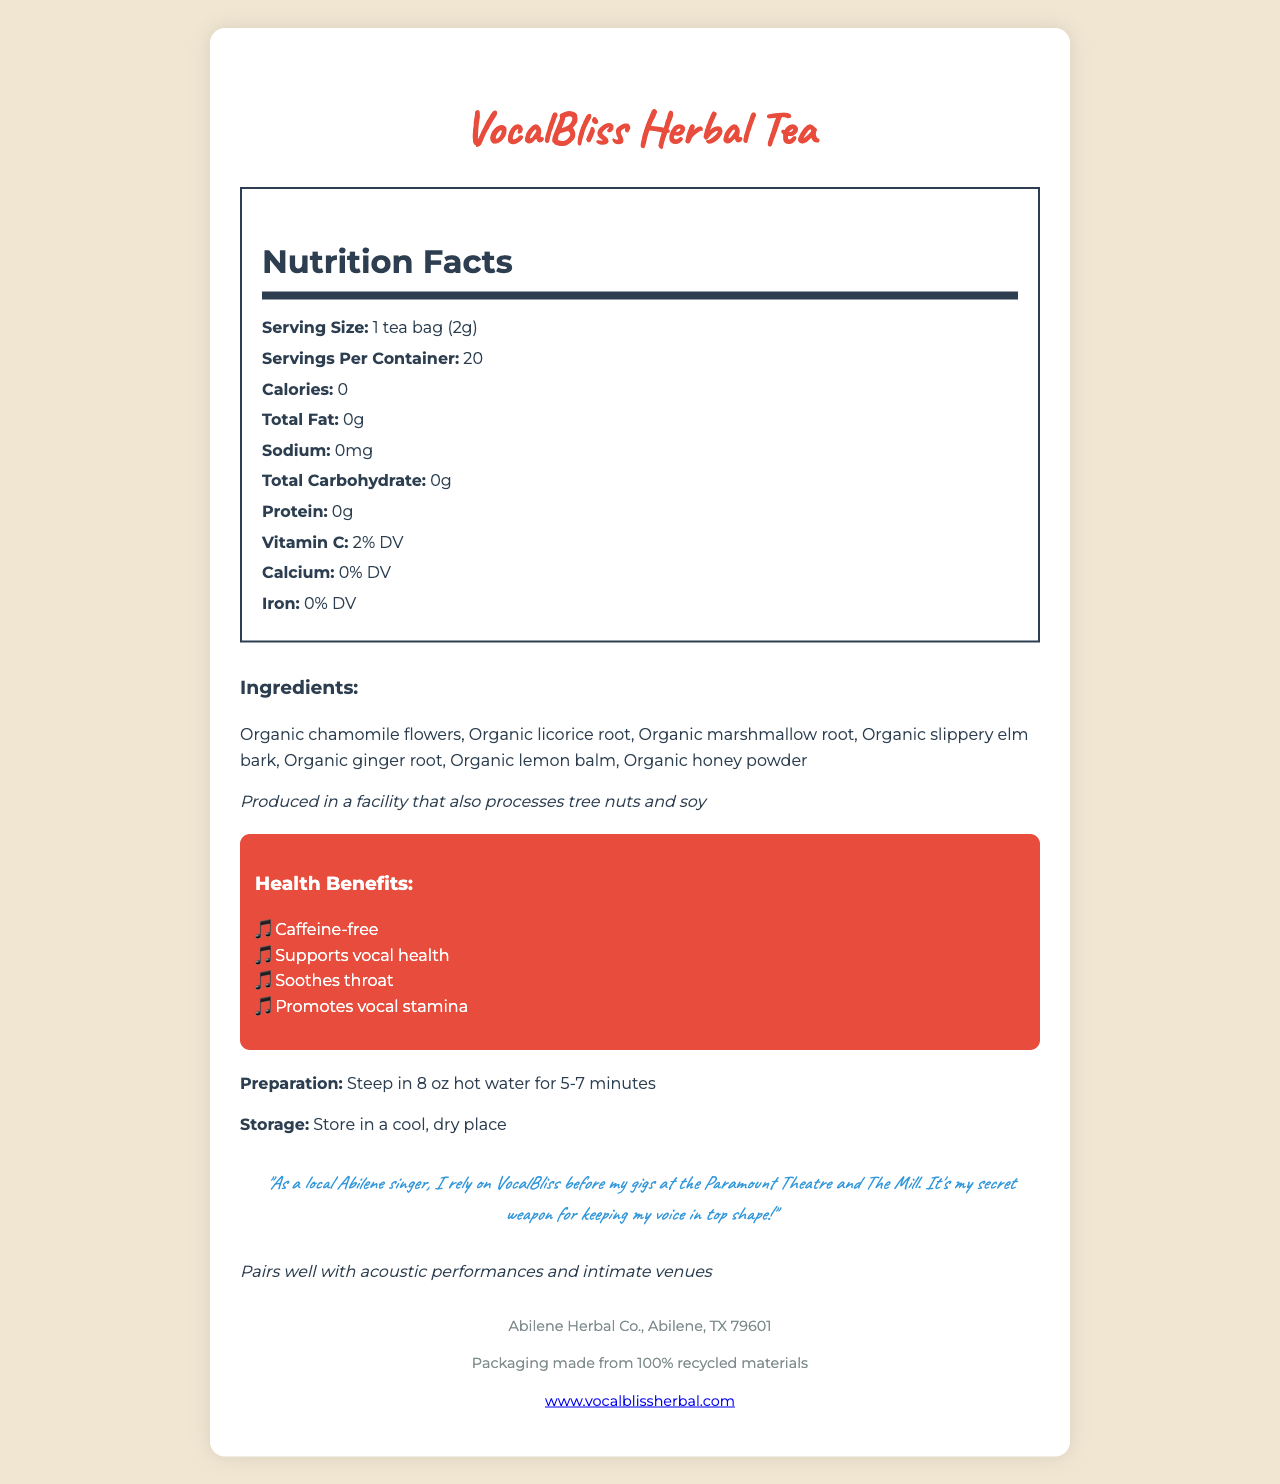what is the serving size of VocalBliss Herbal Tea? The document lists the serving size directly in the Nutrition Facts section as "1 tea bag (2g)".
Answer: 1 tea bag (2g) how many servings are there in one container? The document specifies there are 20 servings per container in the Nutrition Facts section.
Answer: 20 what is the calorie content per serving? The Nutrition Facts section indicates that the calorie content per serving is 0.
Answer: 0 what ingredient might cause an allergic reaction? The allergen information provided in the document states that it is produced in a facility that also processes tree nuts and soy.
Answer: Produced in a facility that also processes tree nuts and soy how should VocalBliss Herbal Tea be stored? The storage instructions are given as "Store in a cool, dry place" in the relevant section.
Answer: Store in a cool, dry place which manufacturer produces VocalBliss Herbal Tea? A. Herbal Health Co. B. Abilene Herbal Co. C. Texan Tea Co. The manufacturer listed at the bottom of the document is "Abilene Herbal Co."
Answer: B. Abilene Herbal Co. what percentage of Vitamin C is in one serving? The Nutrition Facts section shows that the tea contains 2% of the daily value (DV) of Vitamin C per serving.
Answer: 2% DV which of the following is an ingredient in VocalBliss Herbal Tea? I. Organic chamomile flowers II. Organic licorice root III. Organic ginger root IV. Organic green tea The ingredients list includes Organic chamomile flowers, Organic licorice root, and Organic ginger root but not Organic green tea.
Answer: I, II, and III is VocalBliss Herbal Tea caffeinated? The health benefits section lists "Caffeine-free" as one of the claims.
Answer: No does VocalBliss Herbal Tea contain any sodium? The Nutrition Facts section indicates that the sodium content is 0mg per serving.
Answer: No summarize the main idea of this document. The document showcases the nutritional information, ingredients, health claims, preparation and storage instructions, a singer's testimonial, and the manufacturer details of the VocalBliss Herbal Tea.
Answer: VocalBliss Herbal Tea is a caffeine-free herbal tea blend designed to support vocal health and stamina, containing ingredients like chamomile and ginger, produced by Abilene Herbal Co. can you list the nutritional content of VocalBliss Herbal Tea? The information for Total Fat, Sodium, Total Carbohydrate, and Protein is given as 0g, but the document does not specify any other macronutrient details beyond Vitamin C, Calcium, and Iron.
Answer: No 